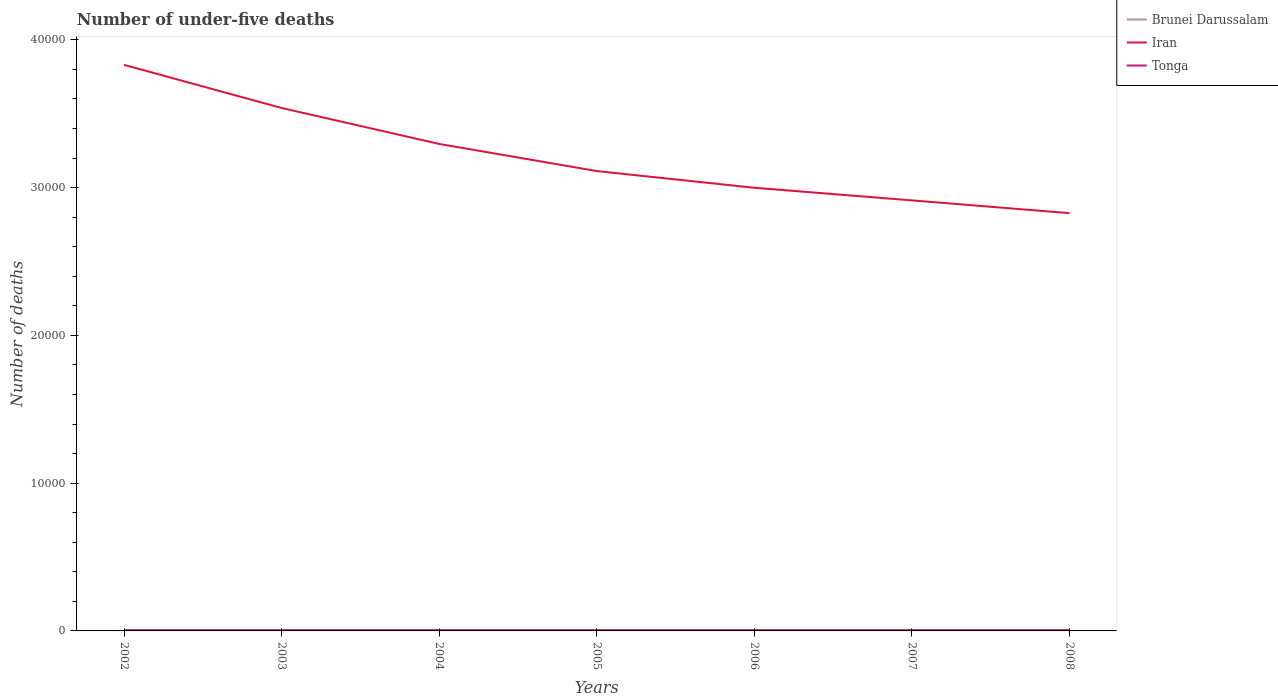Does the line corresponding to Iran intersect with the line corresponding to Brunei Darussalam?
Provide a succinct answer. No. Is the number of lines equal to the number of legend labels?
Offer a very short reply. Yes. Across all years, what is the maximum number of under-five deaths in Tonga?
Keep it short and to the point. 45. What is the total number of under-five deaths in Iran in the graph?
Your response must be concise. 1719. What is the difference between the highest and the second highest number of under-five deaths in Iran?
Offer a very short reply. 1.00e+04. Is the number of under-five deaths in Brunei Darussalam strictly greater than the number of under-five deaths in Tonga over the years?
Your response must be concise. No. How many years are there in the graph?
Make the answer very short. 7. What is the difference between two consecutive major ticks on the Y-axis?
Provide a short and direct response. 10000. Does the graph contain any zero values?
Make the answer very short. No. Does the graph contain grids?
Give a very brief answer. No. How many legend labels are there?
Keep it short and to the point. 3. How are the legend labels stacked?
Make the answer very short. Vertical. What is the title of the graph?
Your response must be concise. Number of under-five deaths. What is the label or title of the Y-axis?
Your answer should be very brief. Number of deaths. What is the Number of deaths of Brunei Darussalam in 2002?
Ensure brevity in your answer.  60. What is the Number of deaths of Iran in 2002?
Offer a terse response. 3.83e+04. What is the Number of deaths in Brunei Darussalam in 2003?
Keep it short and to the point. 59. What is the Number of deaths in Iran in 2003?
Give a very brief answer. 3.54e+04. What is the Number of deaths of Tonga in 2003?
Your response must be concise. 46. What is the Number of deaths of Brunei Darussalam in 2004?
Give a very brief answer. 58. What is the Number of deaths of Iran in 2004?
Keep it short and to the point. 3.30e+04. What is the Number of deaths in Brunei Darussalam in 2005?
Offer a terse response. 57. What is the Number of deaths in Iran in 2005?
Provide a succinct answer. 3.11e+04. What is the Number of deaths in Brunei Darussalam in 2006?
Your answer should be compact. 56. What is the Number of deaths of Iran in 2006?
Your response must be concise. 3.00e+04. What is the Number of deaths of Iran in 2007?
Ensure brevity in your answer.  2.91e+04. What is the Number of deaths of Iran in 2008?
Your answer should be very brief. 2.83e+04. What is the Number of deaths in Tonga in 2008?
Make the answer very short. 49. Across all years, what is the maximum Number of deaths of Iran?
Ensure brevity in your answer.  3.83e+04. Across all years, what is the minimum Number of deaths of Brunei Darussalam?
Provide a succinct answer. 53. Across all years, what is the minimum Number of deaths of Iran?
Provide a short and direct response. 2.83e+04. What is the total Number of deaths of Brunei Darussalam in the graph?
Provide a succinct answer. 397. What is the total Number of deaths of Iran in the graph?
Give a very brief answer. 2.25e+05. What is the total Number of deaths of Tonga in the graph?
Offer a terse response. 333. What is the difference between the Number of deaths in Iran in 2002 and that in 2003?
Keep it short and to the point. 2921. What is the difference between the Number of deaths in Tonga in 2002 and that in 2003?
Offer a very short reply. -1. What is the difference between the Number of deaths in Iran in 2002 and that in 2004?
Provide a short and direct response. 5352. What is the difference between the Number of deaths in Brunei Darussalam in 2002 and that in 2005?
Your answer should be compact. 3. What is the difference between the Number of deaths of Iran in 2002 and that in 2005?
Keep it short and to the point. 7188. What is the difference between the Number of deaths of Tonga in 2002 and that in 2005?
Your response must be concise. -3. What is the difference between the Number of deaths of Iran in 2002 and that in 2006?
Ensure brevity in your answer.  8318. What is the difference between the Number of deaths of Brunei Darussalam in 2002 and that in 2007?
Keep it short and to the point. 6. What is the difference between the Number of deaths of Iran in 2002 and that in 2007?
Offer a terse response. 9172. What is the difference between the Number of deaths of Brunei Darussalam in 2002 and that in 2008?
Your answer should be compact. 7. What is the difference between the Number of deaths in Iran in 2002 and that in 2008?
Keep it short and to the point. 1.00e+04. What is the difference between the Number of deaths in Tonga in 2002 and that in 2008?
Your answer should be very brief. -4. What is the difference between the Number of deaths in Brunei Darussalam in 2003 and that in 2004?
Offer a terse response. 1. What is the difference between the Number of deaths in Iran in 2003 and that in 2004?
Your response must be concise. 2431. What is the difference between the Number of deaths of Iran in 2003 and that in 2005?
Your answer should be compact. 4267. What is the difference between the Number of deaths in Iran in 2003 and that in 2006?
Keep it short and to the point. 5397. What is the difference between the Number of deaths of Brunei Darussalam in 2003 and that in 2007?
Give a very brief answer. 5. What is the difference between the Number of deaths of Iran in 2003 and that in 2007?
Provide a succinct answer. 6251. What is the difference between the Number of deaths in Brunei Darussalam in 2003 and that in 2008?
Provide a short and direct response. 6. What is the difference between the Number of deaths in Iran in 2003 and that in 2008?
Keep it short and to the point. 7116. What is the difference between the Number of deaths of Tonga in 2003 and that in 2008?
Provide a succinct answer. -3. What is the difference between the Number of deaths in Iran in 2004 and that in 2005?
Offer a terse response. 1836. What is the difference between the Number of deaths in Iran in 2004 and that in 2006?
Your response must be concise. 2966. What is the difference between the Number of deaths of Brunei Darussalam in 2004 and that in 2007?
Keep it short and to the point. 4. What is the difference between the Number of deaths of Iran in 2004 and that in 2007?
Provide a short and direct response. 3820. What is the difference between the Number of deaths in Tonga in 2004 and that in 2007?
Your answer should be compact. -2. What is the difference between the Number of deaths in Brunei Darussalam in 2004 and that in 2008?
Provide a short and direct response. 5. What is the difference between the Number of deaths in Iran in 2004 and that in 2008?
Your answer should be very brief. 4685. What is the difference between the Number of deaths of Tonga in 2004 and that in 2008?
Keep it short and to the point. -2. What is the difference between the Number of deaths of Brunei Darussalam in 2005 and that in 2006?
Provide a short and direct response. 1. What is the difference between the Number of deaths in Iran in 2005 and that in 2006?
Make the answer very short. 1130. What is the difference between the Number of deaths in Tonga in 2005 and that in 2006?
Keep it short and to the point. -1. What is the difference between the Number of deaths in Brunei Darussalam in 2005 and that in 2007?
Offer a terse response. 3. What is the difference between the Number of deaths of Iran in 2005 and that in 2007?
Offer a very short reply. 1984. What is the difference between the Number of deaths of Tonga in 2005 and that in 2007?
Your response must be concise. -1. What is the difference between the Number of deaths of Iran in 2005 and that in 2008?
Give a very brief answer. 2849. What is the difference between the Number of deaths in Tonga in 2005 and that in 2008?
Give a very brief answer. -1. What is the difference between the Number of deaths of Brunei Darussalam in 2006 and that in 2007?
Your answer should be very brief. 2. What is the difference between the Number of deaths in Iran in 2006 and that in 2007?
Ensure brevity in your answer.  854. What is the difference between the Number of deaths of Tonga in 2006 and that in 2007?
Provide a short and direct response. 0. What is the difference between the Number of deaths of Brunei Darussalam in 2006 and that in 2008?
Keep it short and to the point. 3. What is the difference between the Number of deaths in Iran in 2006 and that in 2008?
Provide a succinct answer. 1719. What is the difference between the Number of deaths in Brunei Darussalam in 2007 and that in 2008?
Provide a succinct answer. 1. What is the difference between the Number of deaths of Iran in 2007 and that in 2008?
Ensure brevity in your answer.  865. What is the difference between the Number of deaths in Tonga in 2007 and that in 2008?
Offer a terse response. 0. What is the difference between the Number of deaths of Brunei Darussalam in 2002 and the Number of deaths of Iran in 2003?
Offer a terse response. -3.53e+04. What is the difference between the Number of deaths of Iran in 2002 and the Number of deaths of Tonga in 2003?
Keep it short and to the point. 3.83e+04. What is the difference between the Number of deaths in Brunei Darussalam in 2002 and the Number of deaths in Iran in 2004?
Provide a succinct answer. -3.29e+04. What is the difference between the Number of deaths of Brunei Darussalam in 2002 and the Number of deaths of Tonga in 2004?
Provide a succinct answer. 13. What is the difference between the Number of deaths in Iran in 2002 and the Number of deaths in Tonga in 2004?
Offer a terse response. 3.83e+04. What is the difference between the Number of deaths of Brunei Darussalam in 2002 and the Number of deaths of Iran in 2005?
Offer a terse response. -3.11e+04. What is the difference between the Number of deaths of Brunei Darussalam in 2002 and the Number of deaths of Tonga in 2005?
Offer a very short reply. 12. What is the difference between the Number of deaths in Iran in 2002 and the Number of deaths in Tonga in 2005?
Provide a short and direct response. 3.83e+04. What is the difference between the Number of deaths of Brunei Darussalam in 2002 and the Number of deaths of Iran in 2006?
Offer a terse response. -2.99e+04. What is the difference between the Number of deaths in Brunei Darussalam in 2002 and the Number of deaths in Tonga in 2006?
Offer a very short reply. 11. What is the difference between the Number of deaths of Iran in 2002 and the Number of deaths of Tonga in 2006?
Provide a succinct answer. 3.83e+04. What is the difference between the Number of deaths of Brunei Darussalam in 2002 and the Number of deaths of Iran in 2007?
Provide a short and direct response. -2.91e+04. What is the difference between the Number of deaths of Brunei Darussalam in 2002 and the Number of deaths of Tonga in 2007?
Provide a short and direct response. 11. What is the difference between the Number of deaths in Iran in 2002 and the Number of deaths in Tonga in 2007?
Offer a terse response. 3.83e+04. What is the difference between the Number of deaths in Brunei Darussalam in 2002 and the Number of deaths in Iran in 2008?
Give a very brief answer. -2.82e+04. What is the difference between the Number of deaths of Brunei Darussalam in 2002 and the Number of deaths of Tonga in 2008?
Offer a terse response. 11. What is the difference between the Number of deaths of Iran in 2002 and the Number of deaths of Tonga in 2008?
Offer a very short reply. 3.83e+04. What is the difference between the Number of deaths in Brunei Darussalam in 2003 and the Number of deaths in Iran in 2004?
Provide a succinct answer. -3.29e+04. What is the difference between the Number of deaths of Iran in 2003 and the Number of deaths of Tonga in 2004?
Provide a succinct answer. 3.53e+04. What is the difference between the Number of deaths of Brunei Darussalam in 2003 and the Number of deaths of Iran in 2005?
Ensure brevity in your answer.  -3.11e+04. What is the difference between the Number of deaths in Iran in 2003 and the Number of deaths in Tonga in 2005?
Provide a succinct answer. 3.53e+04. What is the difference between the Number of deaths in Brunei Darussalam in 2003 and the Number of deaths in Iran in 2006?
Make the answer very short. -2.99e+04. What is the difference between the Number of deaths in Iran in 2003 and the Number of deaths in Tonga in 2006?
Your response must be concise. 3.53e+04. What is the difference between the Number of deaths of Brunei Darussalam in 2003 and the Number of deaths of Iran in 2007?
Offer a very short reply. -2.91e+04. What is the difference between the Number of deaths of Iran in 2003 and the Number of deaths of Tonga in 2007?
Ensure brevity in your answer.  3.53e+04. What is the difference between the Number of deaths in Brunei Darussalam in 2003 and the Number of deaths in Iran in 2008?
Your answer should be very brief. -2.82e+04. What is the difference between the Number of deaths of Iran in 2003 and the Number of deaths of Tonga in 2008?
Your answer should be compact. 3.53e+04. What is the difference between the Number of deaths in Brunei Darussalam in 2004 and the Number of deaths in Iran in 2005?
Offer a very short reply. -3.11e+04. What is the difference between the Number of deaths in Iran in 2004 and the Number of deaths in Tonga in 2005?
Ensure brevity in your answer.  3.29e+04. What is the difference between the Number of deaths of Brunei Darussalam in 2004 and the Number of deaths of Iran in 2006?
Keep it short and to the point. -2.99e+04. What is the difference between the Number of deaths of Brunei Darussalam in 2004 and the Number of deaths of Tonga in 2006?
Make the answer very short. 9. What is the difference between the Number of deaths of Iran in 2004 and the Number of deaths of Tonga in 2006?
Your response must be concise. 3.29e+04. What is the difference between the Number of deaths of Brunei Darussalam in 2004 and the Number of deaths of Iran in 2007?
Offer a very short reply. -2.91e+04. What is the difference between the Number of deaths of Brunei Darussalam in 2004 and the Number of deaths of Tonga in 2007?
Provide a short and direct response. 9. What is the difference between the Number of deaths of Iran in 2004 and the Number of deaths of Tonga in 2007?
Your answer should be compact. 3.29e+04. What is the difference between the Number of deaths in Brunei Darussalam in 2004 and the Number of deaths in Iran in 2008?
Provide a short and direct response. -2.82e+04. What is the difference between the Number of deaths of Brunei Darussalam in 2004 and the Number of deaths of Tonga in 2008?
Give a very brief answer. 9. What is the difference between the Number of deaths in Iran in 2004 and the Number of deaths in Tonga in 2008?
Provide a short and direct response. 3.29e+04. What is the difference between the Number of deaths of Brunei Darussalam in 2005 and the Number of deaths of Iran in 2006?
Provide a succinct answer. -2.99e+04. What is the difference between the Number of deaths of Brunei Darussalam in 2005 and the Number of deaths of Tonga in 2006?
Provide a short and direct response. 8. What is the difference between the Number of deaths of Iran in 2005 and the Number of deaths of Tonga in 2006?
Provide a short and direct response. 3.11e+04. What is the difference between the Number of deaths of Brunei Darussalam in 2005 and the Number of deaths of Iran in 2007?
Your answer should be compact. -2.91e+04. What is the difference between the Number of deaths of Iran in 2005 and the Number of deaths of Tonga in 2007?
Your answer should be compact. 3.11e+04. What is the difference between the Number of deaths in Brunei Darussalam in 2005 and the Number of deaths in Iran in 2008?
Your response must be concise. -2.82e+04. What is the difference between the Number of deaths in Brunei Darussalam in 2005 and the Number of deaths in Tonga in 2008?
Give a very brief answer. 8. What is the difference between the Number of deaths of Iran in 2005 and the Number of deaths of Tonga in 2008?
Make the answer very short. 3.11e+04. What is the difference between the Number of deaths in Brunei Darussalam in 2006 and the Number of deaths in Iran in 2007?
Provide a short and direct response. -2.91e+04. What is the difference between the Number of deaths in Brunei Darussalam in 2006 and the Number of deaths in Tonga in 2007?
Make the answer very short. 7. What is the difference between the Number of deaths in Iran in 2006 and the Number of deaths in Tonga in 2007?
Your answer should be very brief. 2.99e+04. What is the difference between the Number of deaths of Brunei Darussalam in 2006 and the Number of deaths of Iran in 2008?
Keep it short and to the point. -2.82e+04. What is the difference between the Number of deaths of Brunei Darussalam in 2006 and the Number of deaths of Tonga in 2008?
Give a very brief answer. 7. What is the difference between the Number of deaths of Iran in 2006 and the Number of deaths of Tonga in 2008?
Offer a very short reply. 2.99e+04. What is the difference between the Number of deaths of Brunei Darussalam in 2007 and the Number of deaths of Iran in 2008?
Your answer should be compact. -2.82e+04. What is the difference between the Number of deaths of Brunei Darussalam in 2007 and the Number of deaths of Tonga in 2008?
Your response must be concise. 5. What is the difference between the Number of deaths of Iran in 2007 and the Number of deaths of Tonga in 2008?
Offer a terse response. 2.91e+04. What is the average Number of deaths in Brunei Darussalam per year?
Ensure brevity in your answer.  56.71. What is the average Number of deaths of Iran per year?
Your answer should be very brief. 3.22e+04. What is the average Number of deaths in Tonga per year?
Your answer should be compact. 47.57. In the year 2002, what is the difference between the Number of deaths of Brunei Darussalam and Number of deaths of Iran?
Offer a terse response. -3.82e+04. In the year 2002, what is the difference between the Number of deaths of Brunei Darussalam and Number of deaths of Tonga?
Your answer should be compact. 15. In the year 2002, what is the difference between the Number of deaths of Iran and Number of deaths of Tonga?
Keep it short and to the point. 3.83e+04. In the year 2003, what is the difference between the Number of deaths in Brunei Darussalam and Number of deaths in Iran?
Offer a very short reply. -3.53e+04. In the year 2003, what is the difference between the Number of deaths in Iran and Number of deaths in Tonga?
Your answer should be compact. 3.53e+04. In the year 2004, what is the difference between the Number of deaths in Brunei Darussalam and Number of deaths in Iran?
Your answer should be very brief. -3.29e+04. In the year 2004, what is the difference between the Number of deaths in Brunei Darussalam and Number of deaths in Tonga?
Provide a succinct answer. 11. In the year 2004, what is the difference between the Number of deaths in Iran and Number of deaths in Tonga?
Your answer should be compact. 3.29e+04. In the year 2005, what is the difference between the Number of deaths in Brunei Darussalam and Number of deaths in Iran?
Keep it short and to the point. -3.11e+04. In the year 2005, what is the difference between the Number of deaths in Brunei Darussalam and Number of deaths in Tonga?
Keep it short and to the point. 9. In the year 2005, what is the difference between the Number of deaths of Iran and Number of deaths of Tonga?
Your response must be concise. 3.11e+04. In the year 2006, what is the difference between the Number of deaths in Brunei Darussalam and Number of deaths in Iran?
Keep it short and to the point. -2.99e+04. In the year 2006, what is the difference between the Number of deaths in Brunei Darussalam and Number of deaths in Tonga?
Ensure brevity in your answer.  7. In the year 2006, what is the difference between the Number of deaths in Iran and Number of deaths in Tonga?
Make the answer very short. 2.99e+04. In the year 2007, what is the difference between the Number of deaths in Brunei Darussalam and Number of deaths in Iran?
Offer a very short reply. -2.91e+04. In the year 2007, what is the difference between the Number of deaths of Iran and Number of deaths of Tonga?
Your response must be concise. 2.91e+04. In the year 2008, what is the difference between the Number of deaths of Brunei Darussalam and Number of deaths of Iran?
Your answer should be very brief. -2.82e+04. In the year 2008, what is the difference between the Number of deaths in Iran and Number of deaths in Tonga?
Offer a terse response. 2.82e+04. What is the ratio of the Number of deaths in Brunei Darussalam in 2002 to that in 2003?
Make the answer very short. 1.02. What is the ratio of the Number of deaths in Iran in 2002 to that in 2003?
Make the answer very short. 1.08. What is the ratio of the Number of deaths in Tonga in 2002 to that in 2003?
Keep it short and to the point. 0.98. What is the ratio of the Number of deaths of Brunei Darussalam in 2002 to that in 2004?
Your answer should be compact. 1.03. What is the ratio of the Number of deaths of Iran in 2002 to that in 2004?
Offer a very short reply. 1.16. What is the ratio of the Number of deaths of Tonga in 2002 to that in 2004?
Your answer should be very brief. 0.96. What is the ratio of the Number of deaths in Brunei Darussalam in 2002 to that in 2005?
Ensure brevity in your answer.  1.05. What is the ratio of the Number of deaths of Iran in 2002 to that in 2005?
Your response must be concise. 1.23. What is the ratio of the Number of deaths of Tonga in 2002 to that in 2005?
Offer a terse response. 0.94. What is the ratio of the Number of deaths in Brunei Darussalam in 2002 to that in 2006?
Your answer should be compact. 1.07. What is the ratio of the Number of deaths in Iran in 2002 to that in 2006?
Make the answer very short. 1.28. What is the ratio of the Number of deaths in Tonga in 2002 to that in 2006?
Your answer should be very brief. 0.92. What is the ratio of the Number of deaths of Iran in 2002 to that in 2007?
Provide a succinct answer. 1.31. What is the ratio of the Number of deaths in Tonga in 2002 to that in 2007?
Offer a terse response. 0.92. What is the ratio of the Number of deaths in Brunei Darussalam in 2002 to that in 2008?
Offer a very short reply. 1.13. What is the ratio of the Number of deaths in Iran in 2002 to that in 2008?
Your answer should be compact. 1.35. What is the ratio of the Number of deaths in Tonga in 2002 to that in 2008?
Your answer should be very brief. 0.92. What is the ratio of the Number of deaths in Brunei Darussalam in 2003 to that in 2004?
Provide a succinct answer. 1.02. What is the ratio of the Number of deaths in Iran in 2003 to that in 2004?
Offer a very short reply. 1.07. What is the ratio of the Number of deaths in Tonga in 2003 to that in 2004?
Give a very brief answer. 0.98. What is the ratio of the Number of deaths in Brunei Darussalam in 2003 to that in 2005?
Offer a terse response. 1.04. What is the ratio of the Number of deaths of Iran in 2003 to that in 2005?
Give a very brief answer. 1.14. What is the ratio of the Number of deaths of Brunei Darussalam in 2003 to that in 2006?
Make the answer very short. 1.05. What is the ratio of the Number of deaths of Iran in 2003 to that in 2006?
Offer a terse response. 1.18. What is the ratio of the Number of deaths in Tonga in 2003 to that in 2006?
Provide a succinct answer. 0.94. What is the ratio of the Number of deaths of Brunei Darussalam in 2003 to that in 2007?
Make the answer very short. 1.09. What is the ratio of the Number of deaths in Iran in 2003 to that in 2007?
Provide a succinct answer. 1.21. What is the ratio of the Number of deaths in Tonga in 2003 to that in 2007?
Your answer should be very brief. 0.94. What is the ratio of the Number of deaths of Brunei Darussalam in 2003 to that in 2008?
Your answer should be very brief. 1.11. What is the ratio of the Number of deaths in Iran in 2003 to that in 2008?
Give a very brief answer. 1.25. What is the ratio of the Number of deaths in Tonga in 2003 to that in 2008?
Keep it short and to the point. 0.94. What is the ratio of the Number of deaths in Brunei Darussalam in 2004 to that in 2005?
Your response must be concise. 1.02. What is the ratio of the Number of deaths of Iran in 2004 to that in 2005?
Your response must be concise. 1.06. What is the ratio of the Number of deaths of Tonga in 2004 to that in 2005?
Provide a short and direct response. 0.98. What is the ratio of the Number of deaths in Brunei Darussalam in 2004 to that in 2006?
Provide a succinct answer. 1.04. What is the ratio of the Number of deaths of Iran in 2004 to that in 2006?
Your answer should be very brief. 1.1. What is the ratio of the Number of deaths in Tonga in 2004 to that in 2006?
Make the answer very short. 0.96. What is the ratio of the Number of deaths of Brunei Darussalam in 2004 to that in 2007?
Offer a terse response. 1.07. What is the ratio of the Number of deaths of Iran in 2004 to that in 2007?
Make the answer very short. 1.13. What is the ratio of the Number of deaths of Tonga in 2004 to that in 2007?
Make the answer very short. 0.96. What is the ratio of the Number of deaths in Brunei Darussalam in 2004 to that in 2008?
Offer a very short reply. 1.09. What is the ratio of the Number of deaths of Iran in 2004 to that in 2008?
Provide a short and direct response. 1.17. What is the ratio of the Number of deaths of Tonga in 2004 to that in 2008?
Make the answer very short. 0.96. What is the ratio of the Number of deaths of Brunei Darussalam in 2005 to that in 2006?
Offer a terse response. 1.02. What is the ratio of the Number of deaths in Iran in 2005 to that in 2006?
Offer a very short reply. 1.04. What is the ratio of the Number of deaths of Tonga in 2005 to that in 2006?
Your answer should be very brief. 0.98. What is the ratio of the Number of deaths of Brunei Darussalam in 2005 to that in 2007?
Keep it short and to the point. 1.06. What is the ratio of the Number of deaths of Iran in 2005 to that in 2007?
Your answer should be very brief. 1.07. What is the ratio of the Number of deaths in Tonga in 2005 to that in 2007?
Keep it short and to the point. 0.98. What is the ratio of the Number of deaths in Brunei Darussalam in 2005 to that in 2008?
Give a very brief answer. 1.08. What is the ratio of the Number of deaths in Iran in 2005 to that in 2008?
Offer a very short reply. 1.1. What is the ratio of the Number of deaths in Tonga in 2005 to that in 2008?
Provide a short and direct response. 0.98. What is the ratio of the Number of deaths of Iran in 2006 to that in 2007?
Keep it short and to the point. 1.03. What is the ratio of the Number of deaths in Brunei Darussalam in 2006 to that in 2008?
Your answer should be very brief. 1.06. What is the ratio of the Number of deaths in Iran in 2006 to that in 2008?
Your response must be concise. 1.06. What is the ratio of the Number of deaths of Tonga in 2006 to that in 2008?
Keep it short and to the point. 1. What is the ratio of the Number of deaths in Brunei Darussalam in 2007 to that in 2008?
Make the answer very short. 1.02. What is the ratio of the Number of deaths in Iran in 2007 to that in 2008?
Your answer should be compact. 1.03. What is the difference between the highest and the second highest Number of deaths of Brunei Darussalam?
Ensure brevity in your answer.  1. What is the difference between the highest and the second highest Number of deaths of Iran?
Your response must be concise. 2921. What is the difference between the highest and the lowest Number of deaths of Brunei Darussalam?
Keep it short and to the point. 7. What is the difference between the highest and the lowest Number of deaths in Iran?
Make the answer very short. 1.00e+04. What is the difference between the highest and the lowest Number of deaths in Tonga?
Your answer should be compact. 4. 